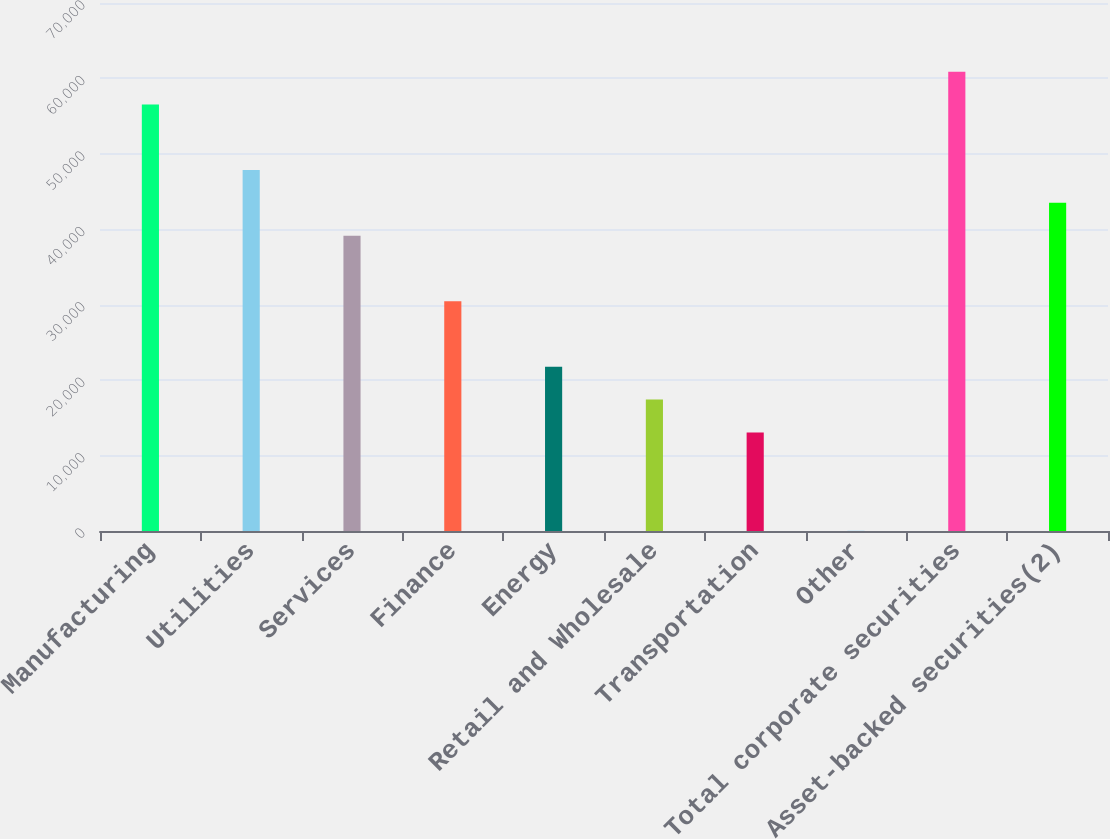<chart> <loc_0><loc_0><loc_500><loc_500><bar_chart><fcel>Manufacturing<fcel>Utilities<fcel>Services<fcel>Finance<fcel>Energy<fcel>Retail and Wholesale<fcel>Transportation<fcel>Other<fcel>Total corporate securities<fcel>Asset-backed securities(2)<nl><fcel>56549.1<fcel>47853.7<fcel>39158.3<fcel>30462.9<fcel>21767.5<fcel>17419.8<fcel>13072.1<fcel>29<fcel>60896.8<fcel>43506<nl></chart> 